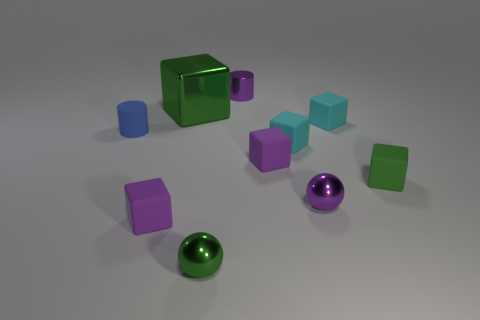Subtract all green metallic cubes. How many cubes are left? 5 Add 8 tiny green metal things. How many tiny green metal things exist? 9 Subtract all purple spheres. How many spheres are left? 1 Subtract 0 red blocks. How many objects are left? 10 Subtract all spheres. How many objects are left? 8 Subtract 4 cubes. How many cubes are left? 2 Subtract all red cylinders. Subtract all purple blocks. How many cylinders are left? 2 Subtract all blue cubes. How many purple spheres are left? 1 Subtract all small cylinders. Subtract all purple objects. How many objects are left? 4 Add 9 blue objects. How many blue objects are left? 10 